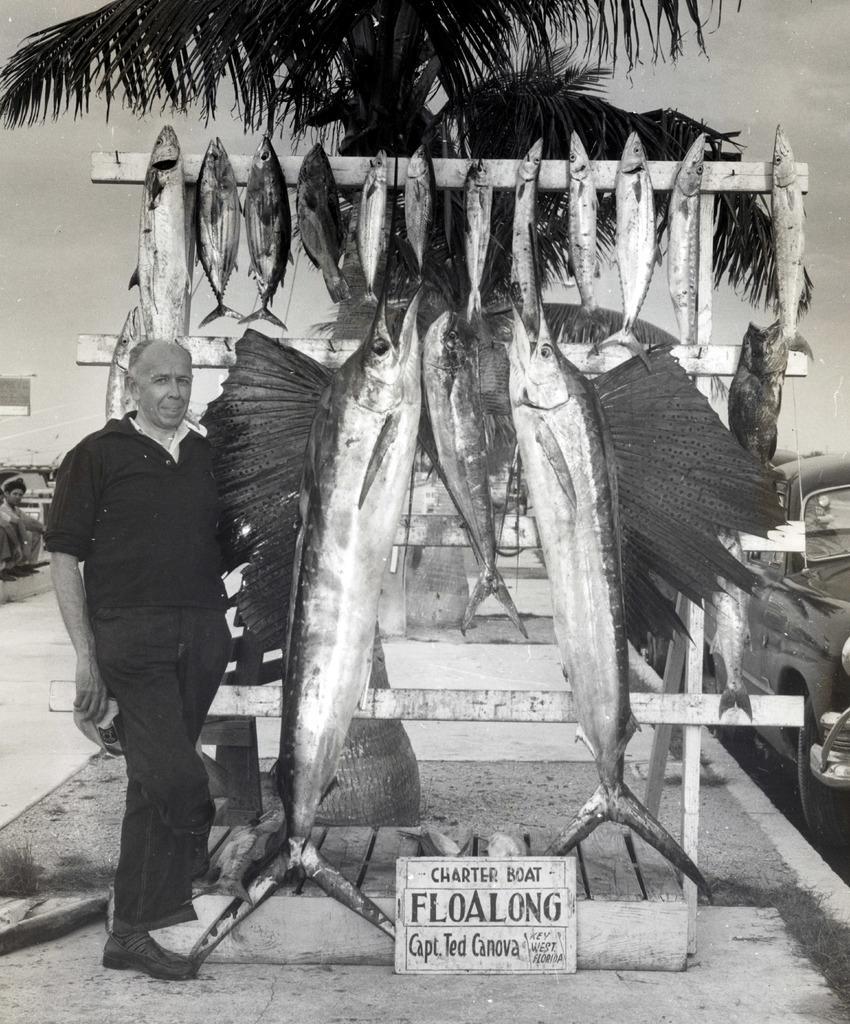Please provide a concise description of this image. In this image we can see a person is standing and holding some object in his hand. There are many fishes hanged to the wooden object. There is a board placed on the ground and some text written on it. There is a sky in the image. There is a tree in the image. There is a vehicle at the right side of the image. There are two persons sitting at the left side of the image. 